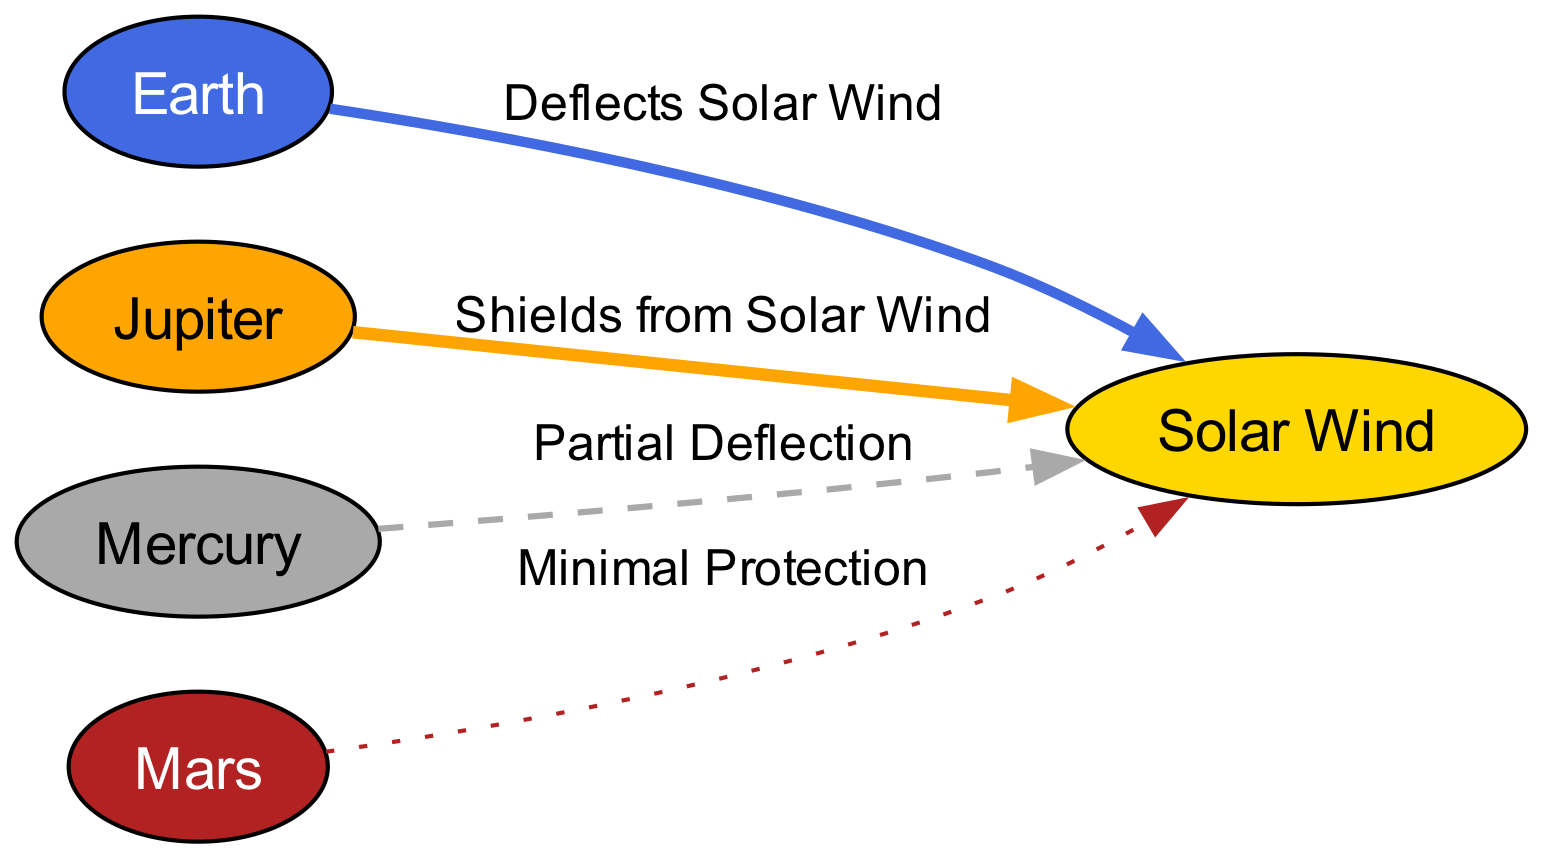What planet has the strongest magnetic field? The diagram indicates that Jupiter possesses the strongest magnetic field among the planets listed. This is evident from the description attached to the Jupiter node, which states, "Has the strongest magnetic field among planets in the Solar System."
Answer: Jupiter How many planets are depicted in the diagram? By counting the nodes shown in the diagram, we identify five entities: Earth, Jupiter, Mercury, Mars, and Solar Wind. Thus, the total number of planets is five.
Answer: 5 Which planet has a weak magnetic field? The diagram specifies that Mercury has a weak magnetic field, which is mentioned in its description: "Weak magnetic field, barely protecting the planet."
Answer: Mercury What type of protection does Mars offer against solar wind? The diagram shows that Mars provides minimal protection against solar wind, as indicated by the label from Mars to Solar Wind: "Minimal Protection."
Answer: Minimal Protection Which planet is indicated as shielding from solar winds? Referring to the edges of the diagram, it is noted that Jupiter shields from solar wind, as clearly labeled in the edge definition "Shields from Solar Wind."
Answer: Jupiter What is the relationship between Earth and Solar Wind in the diagram? The diagram delineates the relationship between Earth and Solar Wind, indicating that Earth "Deflects Solar Wind," suggesting an active defense mechanism against solar particles.
Answer: Deflects Solar Wind How does Mercury's magnetic field relate to solar wind? According to the diagram, Mercury has "Partial Deflection" concerning solar wind. This indicates that while it offers some level of defense, it is not sufficient to provide robust protection.
Answer: Partial Deflection Which node features the strongest visual protective barrier? In assessing the diagram, Jupiter shows a significant protective barrier most clearly. This is supported by it being labeled as "Shields from Solar Wind," depicting strong defense compared to others.
Answer: Jupiter What style is used for the edge between Mercury and Solar Wind? The edge connecting Mercury to Solar Wind is styled as a dashed line, which is represented visually by the specific style attribute "dashed" assigned to the edge between these two nodes.
Answer: Dashed 